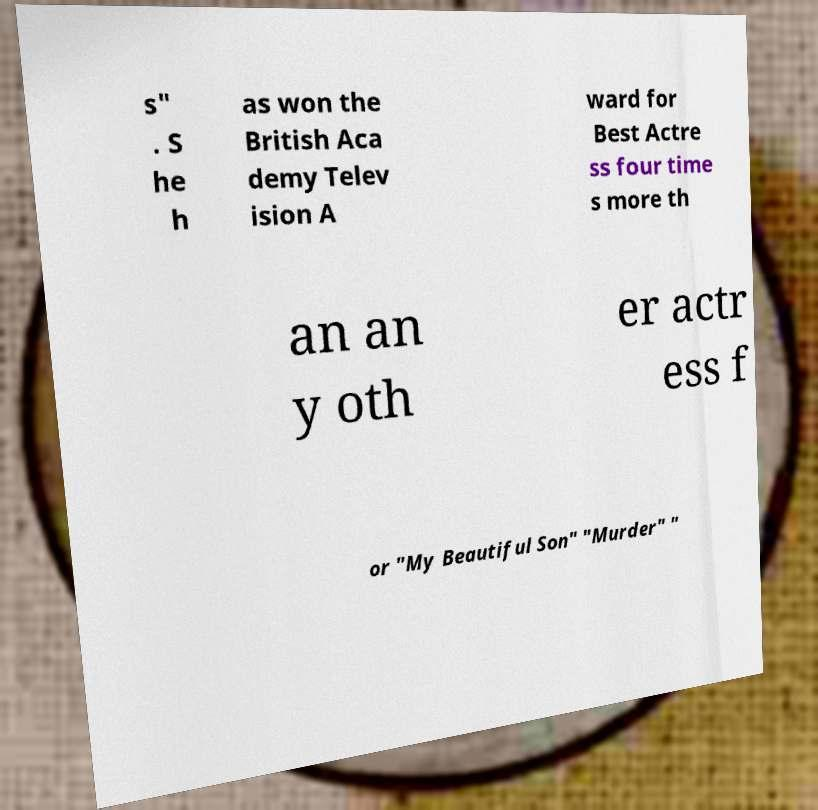What messages or text are displayed in this image? I need them in a readable, typed format. s" . S he h as won the British Aca demy Telev ision A ward for Best Actre ss four time s more th an an y oth er actr ess f or "My Beautiful Son" "Murder" " 